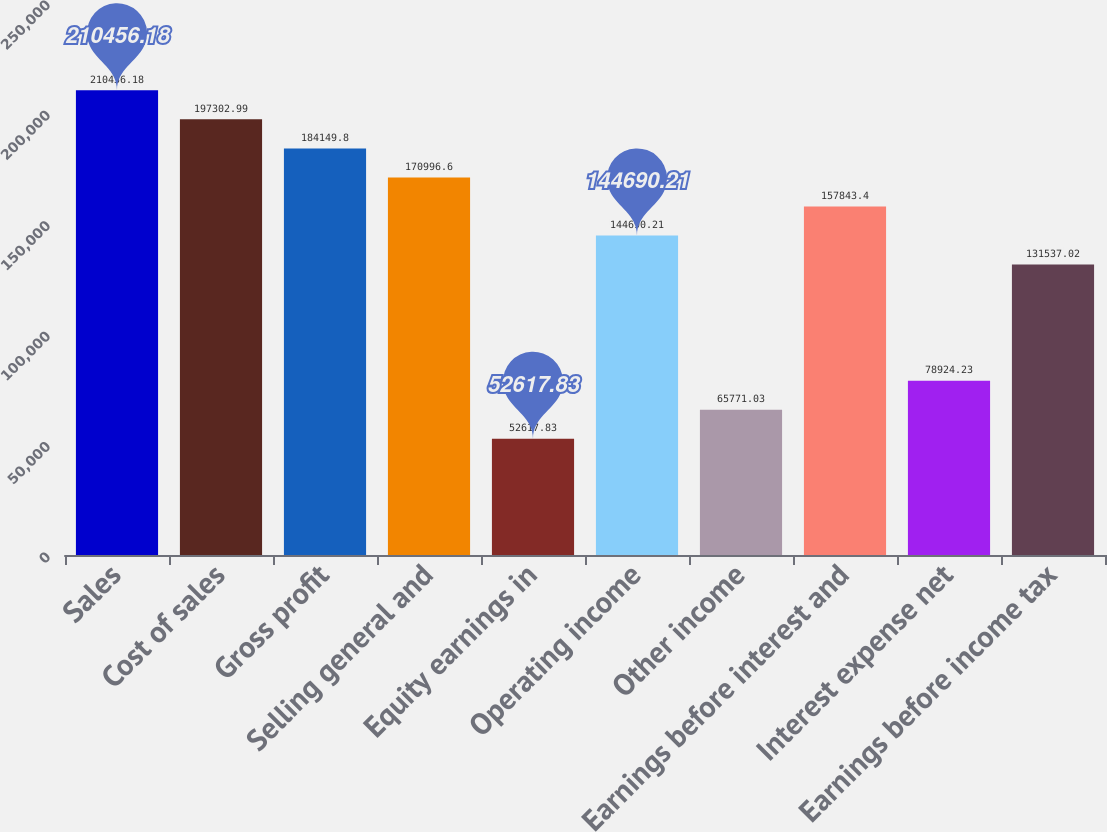<chart> <loc_0><loc_0><loc_500><loc_500><bar_chart><fcel>Sales<fcel>Cost of sales<fcel>Gross profit<fcel>Selling general and<fcel>Equity earnings in<fcel>Operating income<fcel>Other income<fcel>Earnings before interest and<fcel>Interest expense net<fcel>Earnings before income tax<nl><fcel>210456<fcel>197303<fcel>184150<fcel>170997<fcel>52617.8<fcel>144690<fcel>65771<fcel>157843<fcel>78924.2<fcel>131537<nl></chart> 